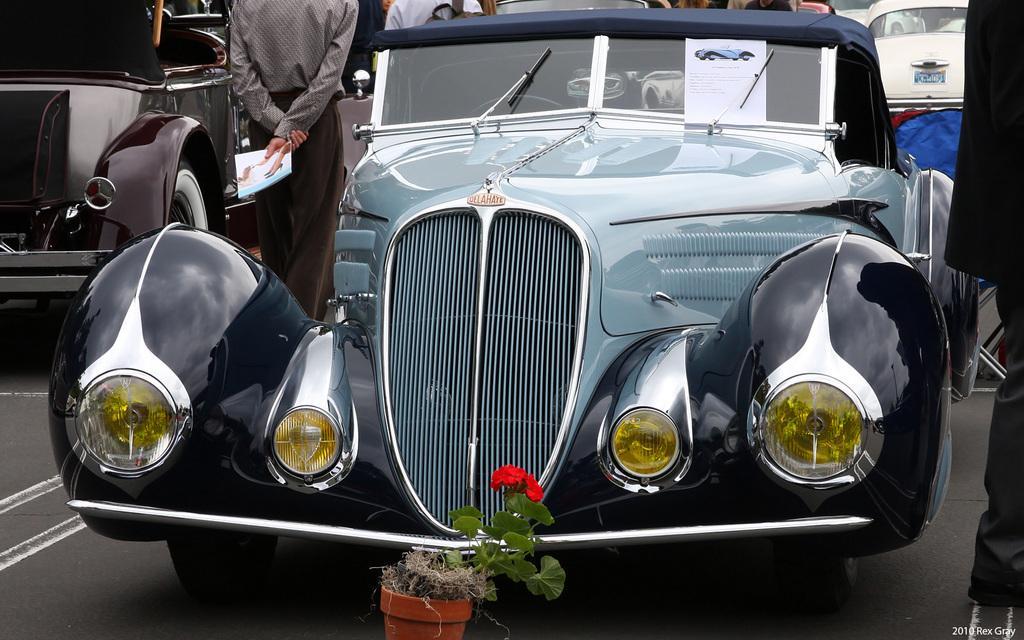Can you describe this image briefly? In front of the image there is a car, in front of the car there is a flower pot, beside the car there is a person standing, in the background of the image there are a few cars parked and there are a few people, at the bottom of the image there is some text. 